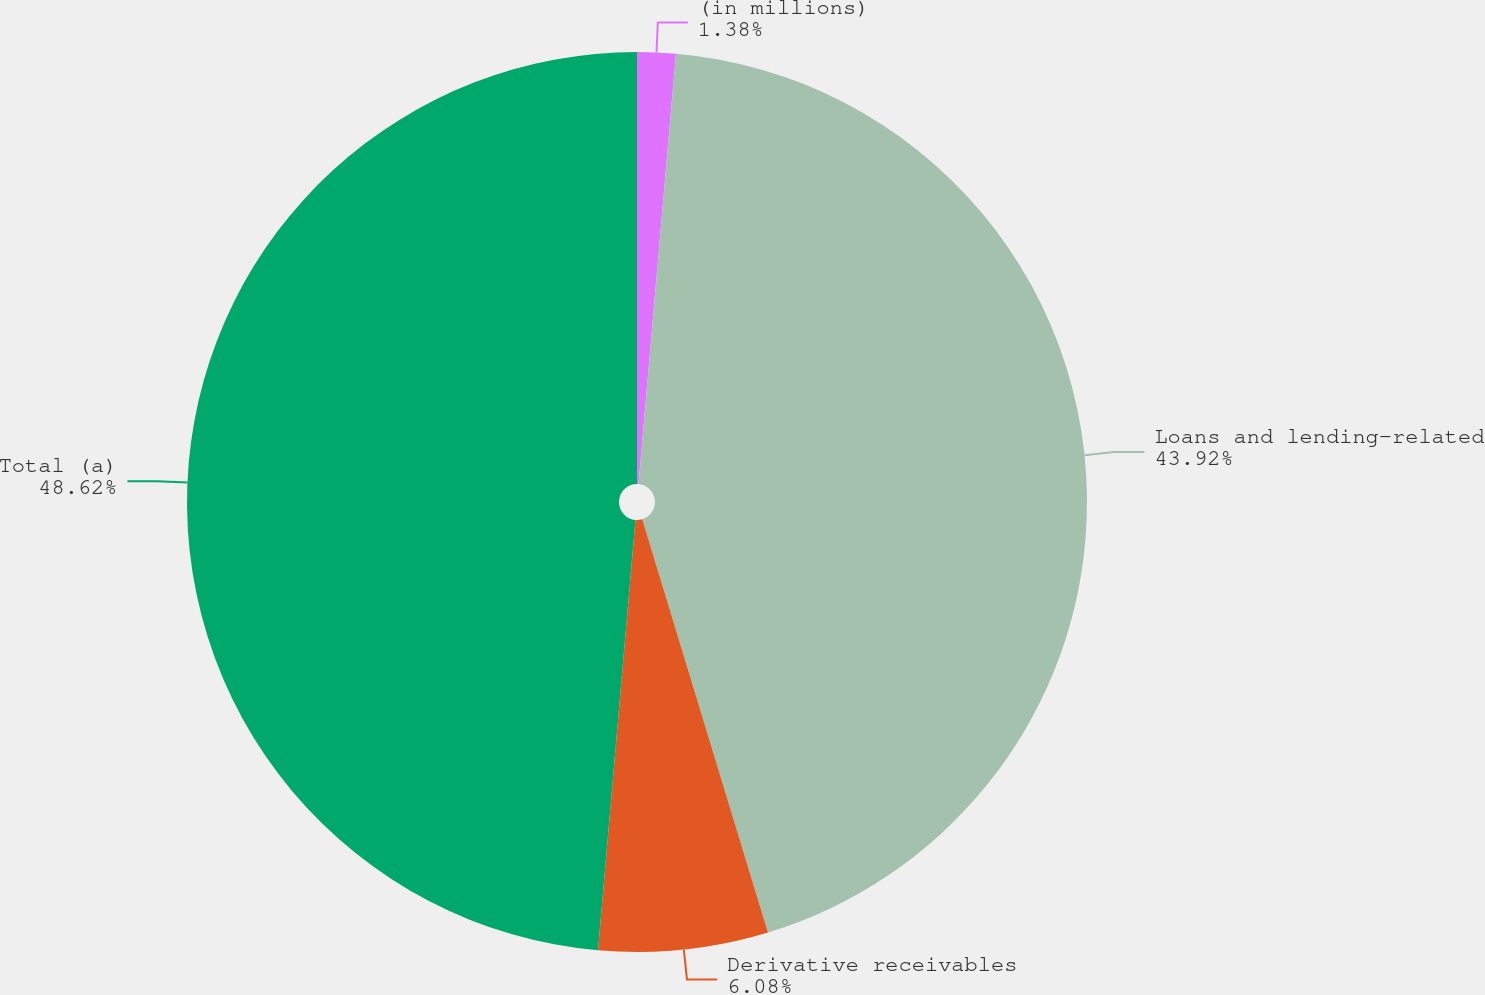<chart> <loc_0><loc_0><loc_500><loc_500><pie_chart><fcel>(in millions)<fcel>Loans and lending-related<fcel>Derivative receivables<fcel>Total (a)<nl><fcel>1.38%<fcel>43.92%<fcel>6.08%<fcel>48.62%<nl></chart> 